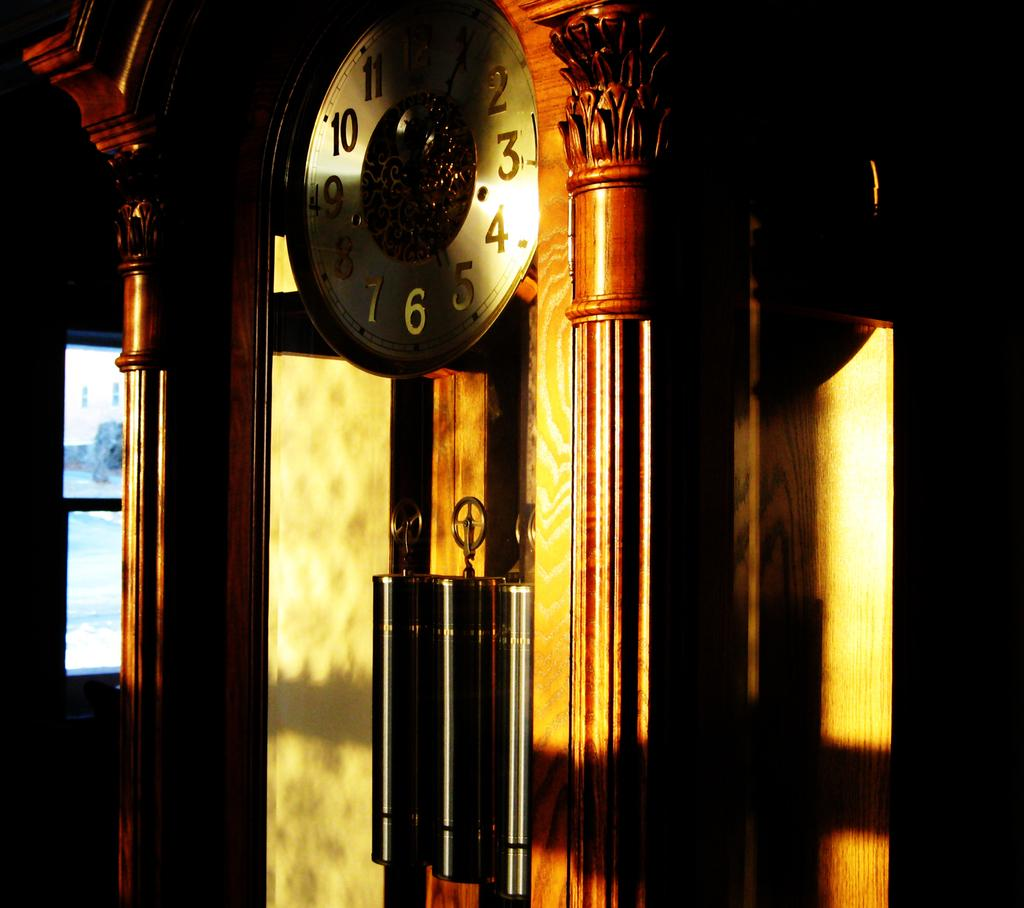<image>
Offer a succinct explanation of the picture presented. Large clock with the number 6 on the bottom sitting in a room. 